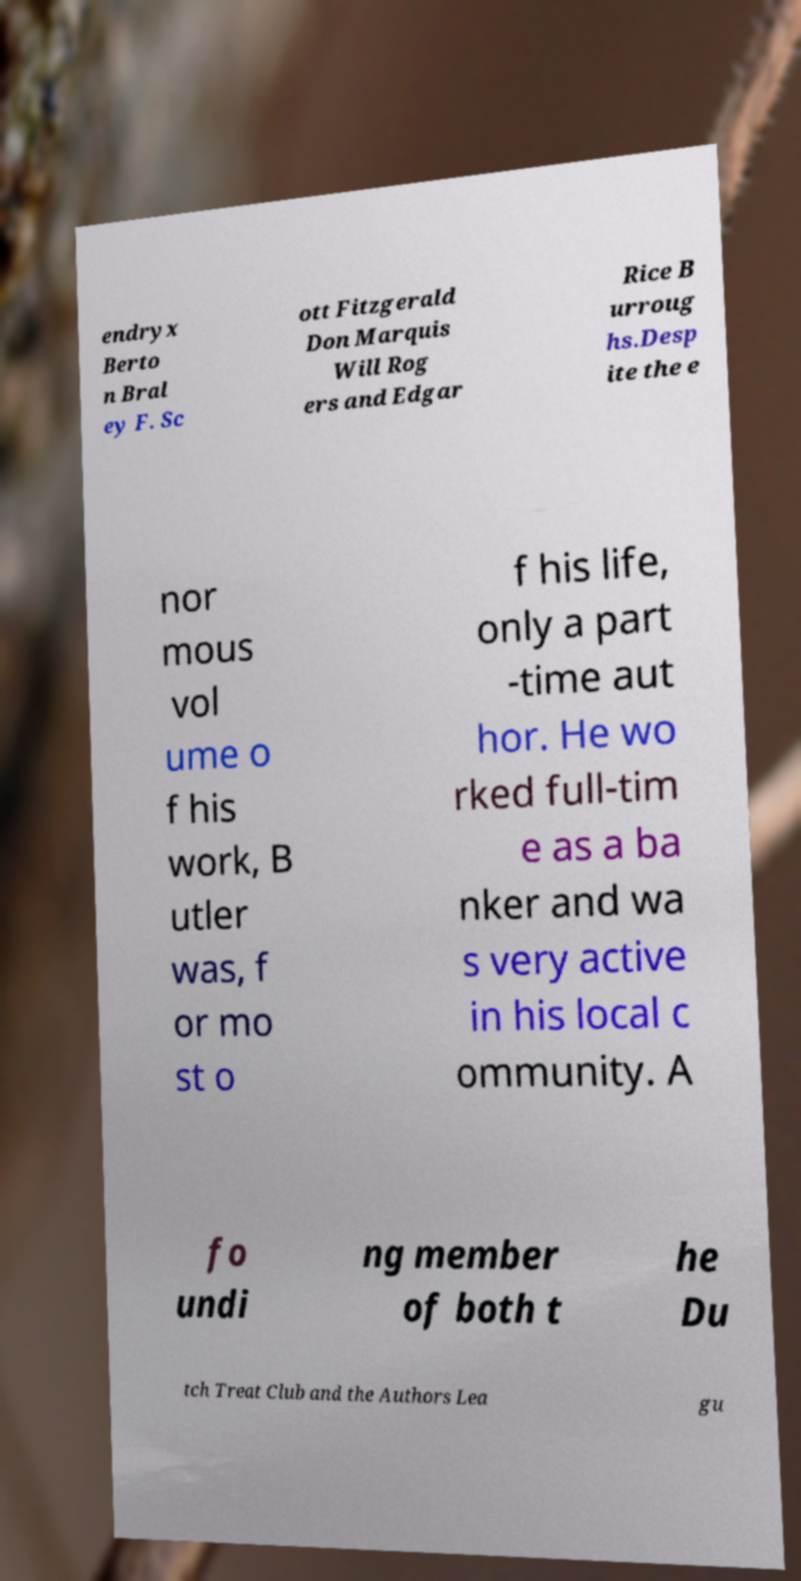Could you assist in decoding the text presented in this image and type it out clearly? endryx Berto n Bral ey F. Sc ott Fitzgerald Don Marquis Will Rog ers and Edgar Rice B urroug hs.Desp ite the e nor mous vol ume o f his work, B utler was, f or mo st o f his life, only a part -time aut hor. He wo rked full-tim e as a ba nker and wa s very active in his local c ommunity. A fo undi ng member of both t he Du tch Treat Club and the Authors Lea gu 